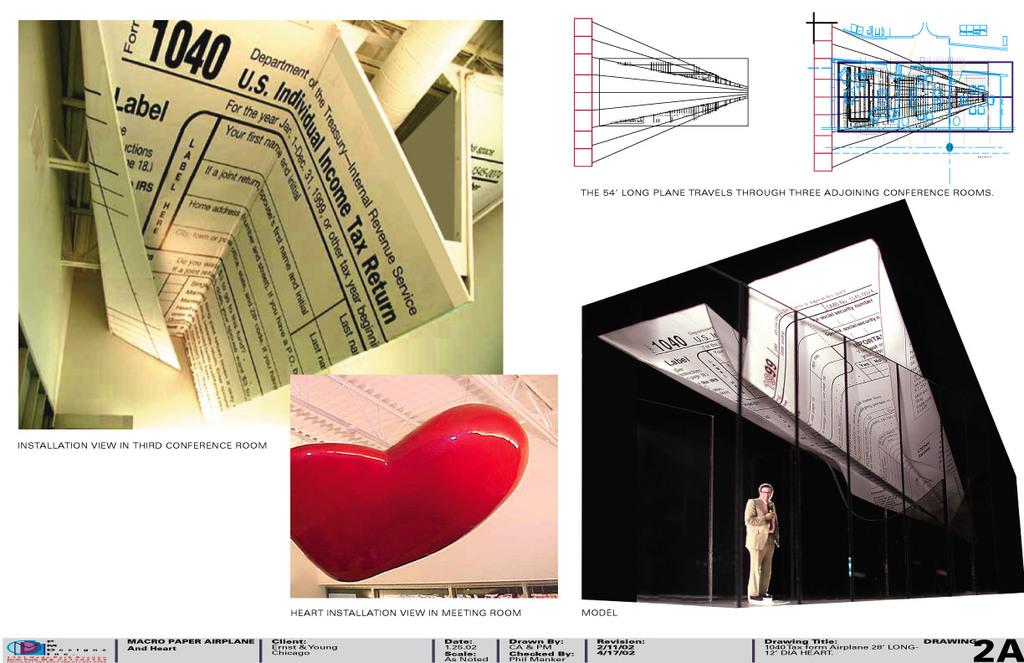What tax form is shown in the upper left?
Offer a terse response. 1040. What country is this for?
Make the answer very short. Us. 